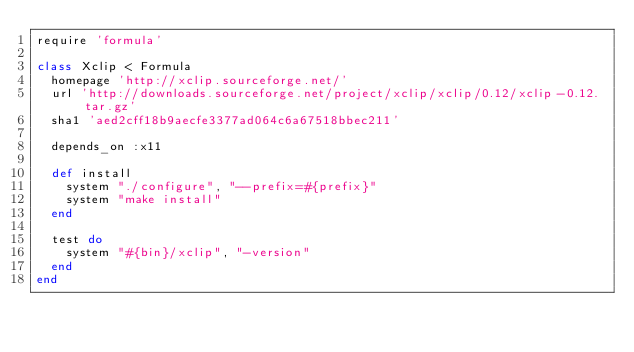Convert code to text. <code><loc_0><loc_0><loc_500><loc_500><_Ruby_>require 'formula'

class Xclip < Formula
  homepage 'http://xclip.sourceforge.net/'
  url 'http://downloads.sourceforge.net/project/xclip/xclip/0.12/xclip-0.12.tar.gz'
  sha1 'aed2cff18b9aecfe3377ad064c6a67518bbec211'

  depends_on :x11

  def install
    system "./configure", "--prefix=#{prefix}"
    system "make install"
  end

  test do
    system "#{bin}/xclip", "-version"
  end
end
</code> 